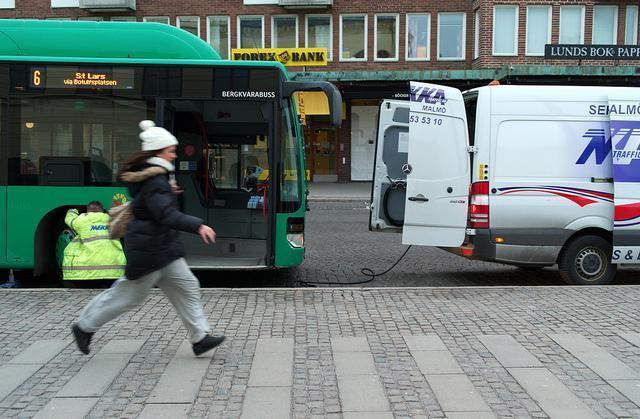How many people are there?
Give a very brief answer. 2. 